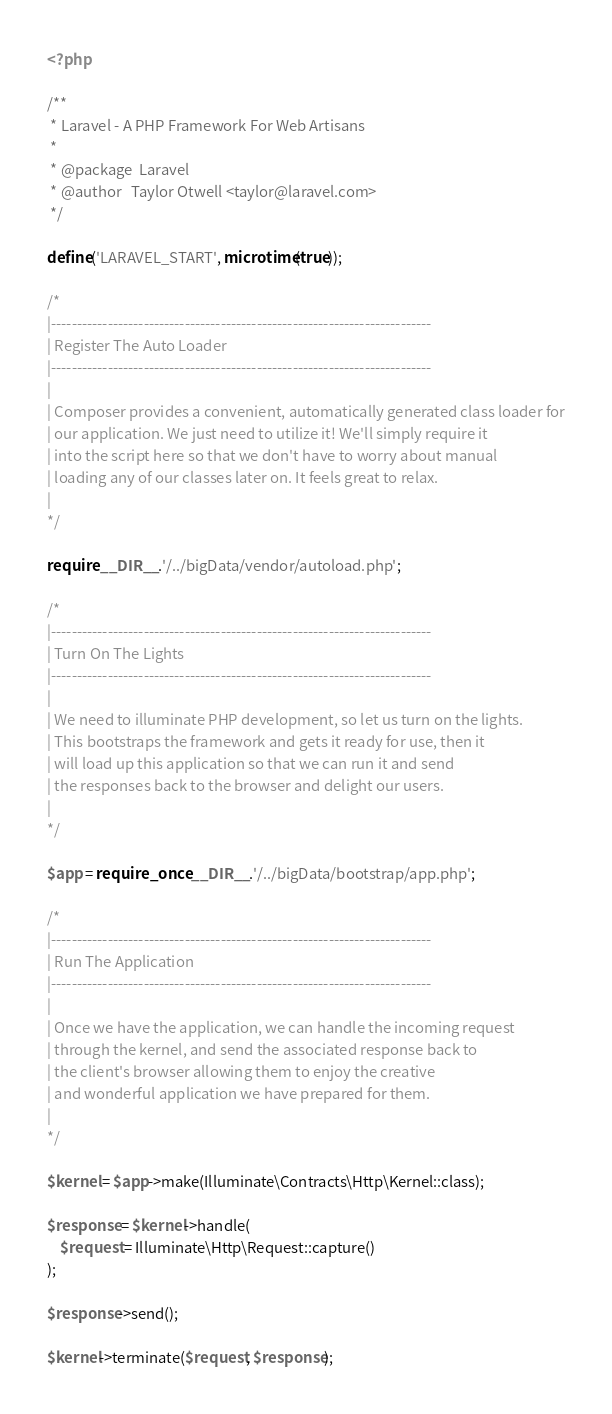Convert code to text. <code><loc_0><loc_0><loc_500><loc_500><_PHP_><?php

/**
 * Laravel - A PHP Framework For Web Artisans
 *
 * @package  Laravel
 * @author   Taylor Otwell <taylor@laravel.com>
 */

define('LARAVEL_START', microtime(true));

/*
|--------------------------------------------------------------------------
| Register The Auto Loader
|--------------------------------------------------------------------------
|
| Composer provides a convenient, automatically generated class loader for
| our application. We just need to utilize it! We'll simply require it
| into the script here so that we don't have to worry about manual
| loading any of our classes later on. It feels great to relax.
|
*/

require __DIR__.'/../bigData/vendor/autoload.php';

/*
|--------------------------------------------------------------------------
| Turn On The Lights
|--------------------------------------------------------------------------
|
| We need to illuminate PHP development, so let us turn on the lights.
| This bootstraps the framework and gets it ready for use, then it
| will load up this application so that we can run it and send
| the responses back to the browser and delight our users.
|
*/

$app = require_once __DIR__.'/../bigData/bootstrap/app.php';

/*
|--------------------------------------------------------------------------
| Run The Application
|--------------------------------------------------------------------------
|
| Once we have the application, we can handle the incoming request
| through the kernel, and send the associated response back to
| the client's browser allowing them to enjoy the creative
| and wonderful application we have prepared for them.
|
*/

$kernel = $app->make(Illuminate\Contracts\Http\Kernel::class);

$response = $kernel->handle(
    $request = Illuminate\Http\Request::capture()
);

$response->send();

$kernel->terminate($request, $response);
</code> 